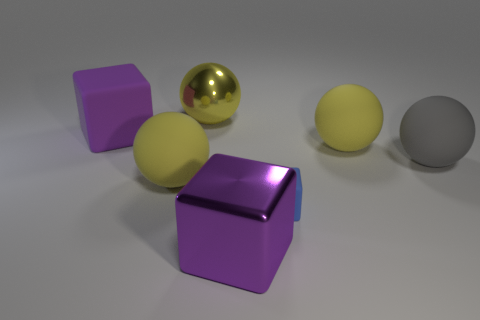There is a gray ball; what number of yellow metal balls are to the right of it?
Provide a short and direct response. 0. What color is the object behind the big cube behind the large metallic object in front of the blue matte cube?
Your response must be concise. Yellow. Does the cube that is in front of the tiny blue thing have the same color as the shiny object that is to the left of the big purple metallic block?
Ensure brevity in your answer.  No. The yellow object in front of the large yellow ball that is to the right of the purple shiny block is what shape?
Offer a terse response. Sphere. Is there a purple rubber cube that has the same size as the gray sphere?
Provide a succinct answer. Yes. How many tiny gray objects have the same shape as the large purple metal object?
Your answer should be very brief. 0. Are there an equal number of blue objects behind the big gray object and blue objects that are right of the tiny matte object?
Offer a terse response. Yes. Are any gray objects visible?
Make the answer very short. Yes. What is the size of the block that is right of the big purple shiny block that is to the right of the purple object behind the big purple shiny cube?
Offer a very short reply. Small. What shape is the purple metallic object that is the same size as the yellow shiny ball?
Offer a very short reply. Cube. 